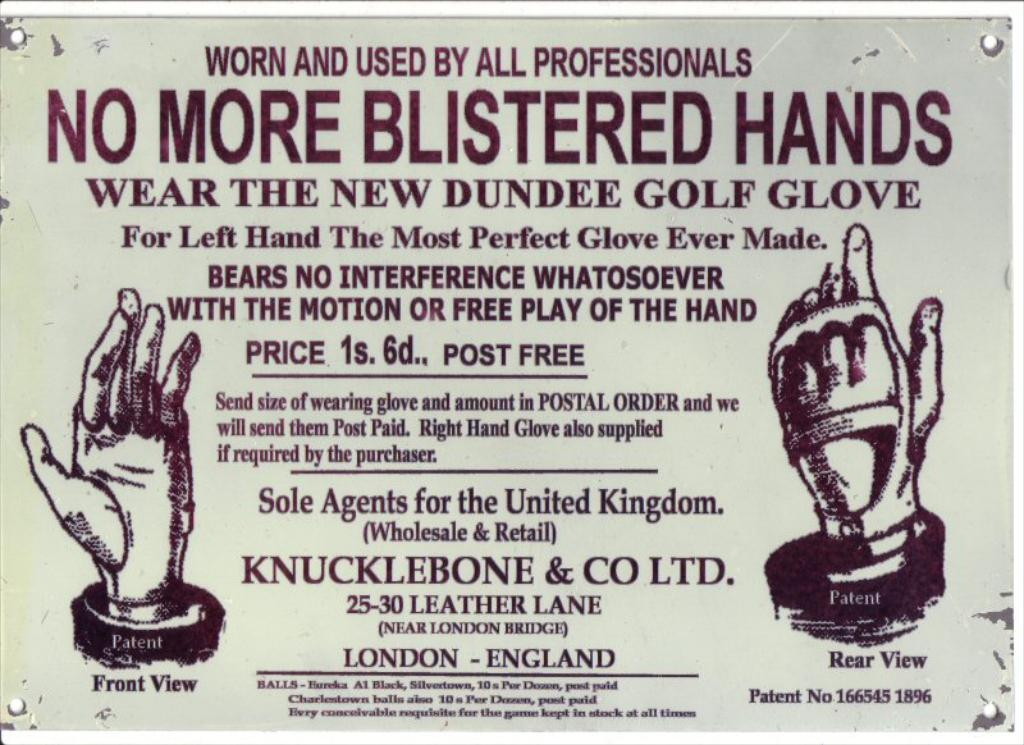<image>
Present a compact description of the photo's key features. Poster that shows a trophy of a hand and says "No more blistered hands". 